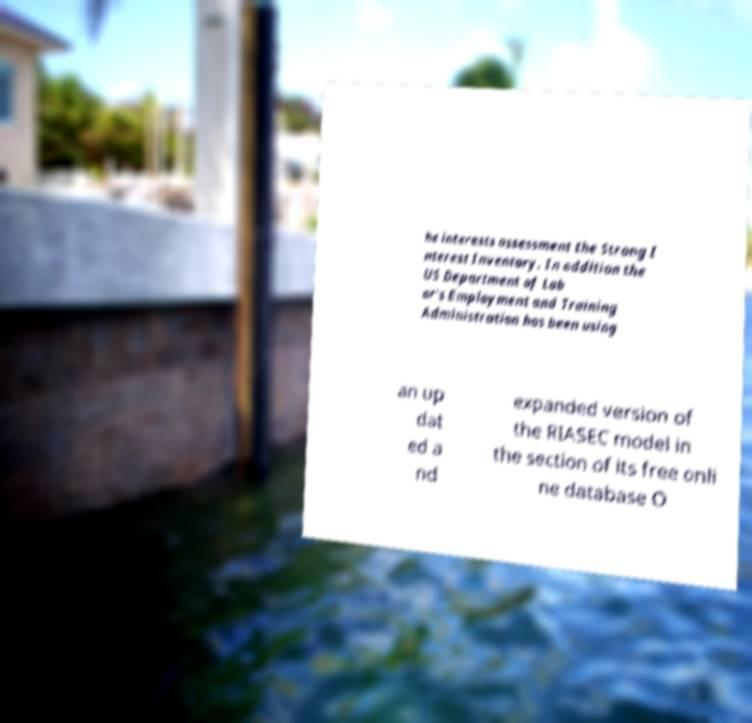For documentation purposes, I need the text within this image transcribed. Could you provide that? he interests assessment the Strong I nterest Inventory. In addition the US Department of Lab or's Employment and Training Administration has been using an up dat ed a nd expanded version of the RIASEC model in the section of its free onli ne database O 